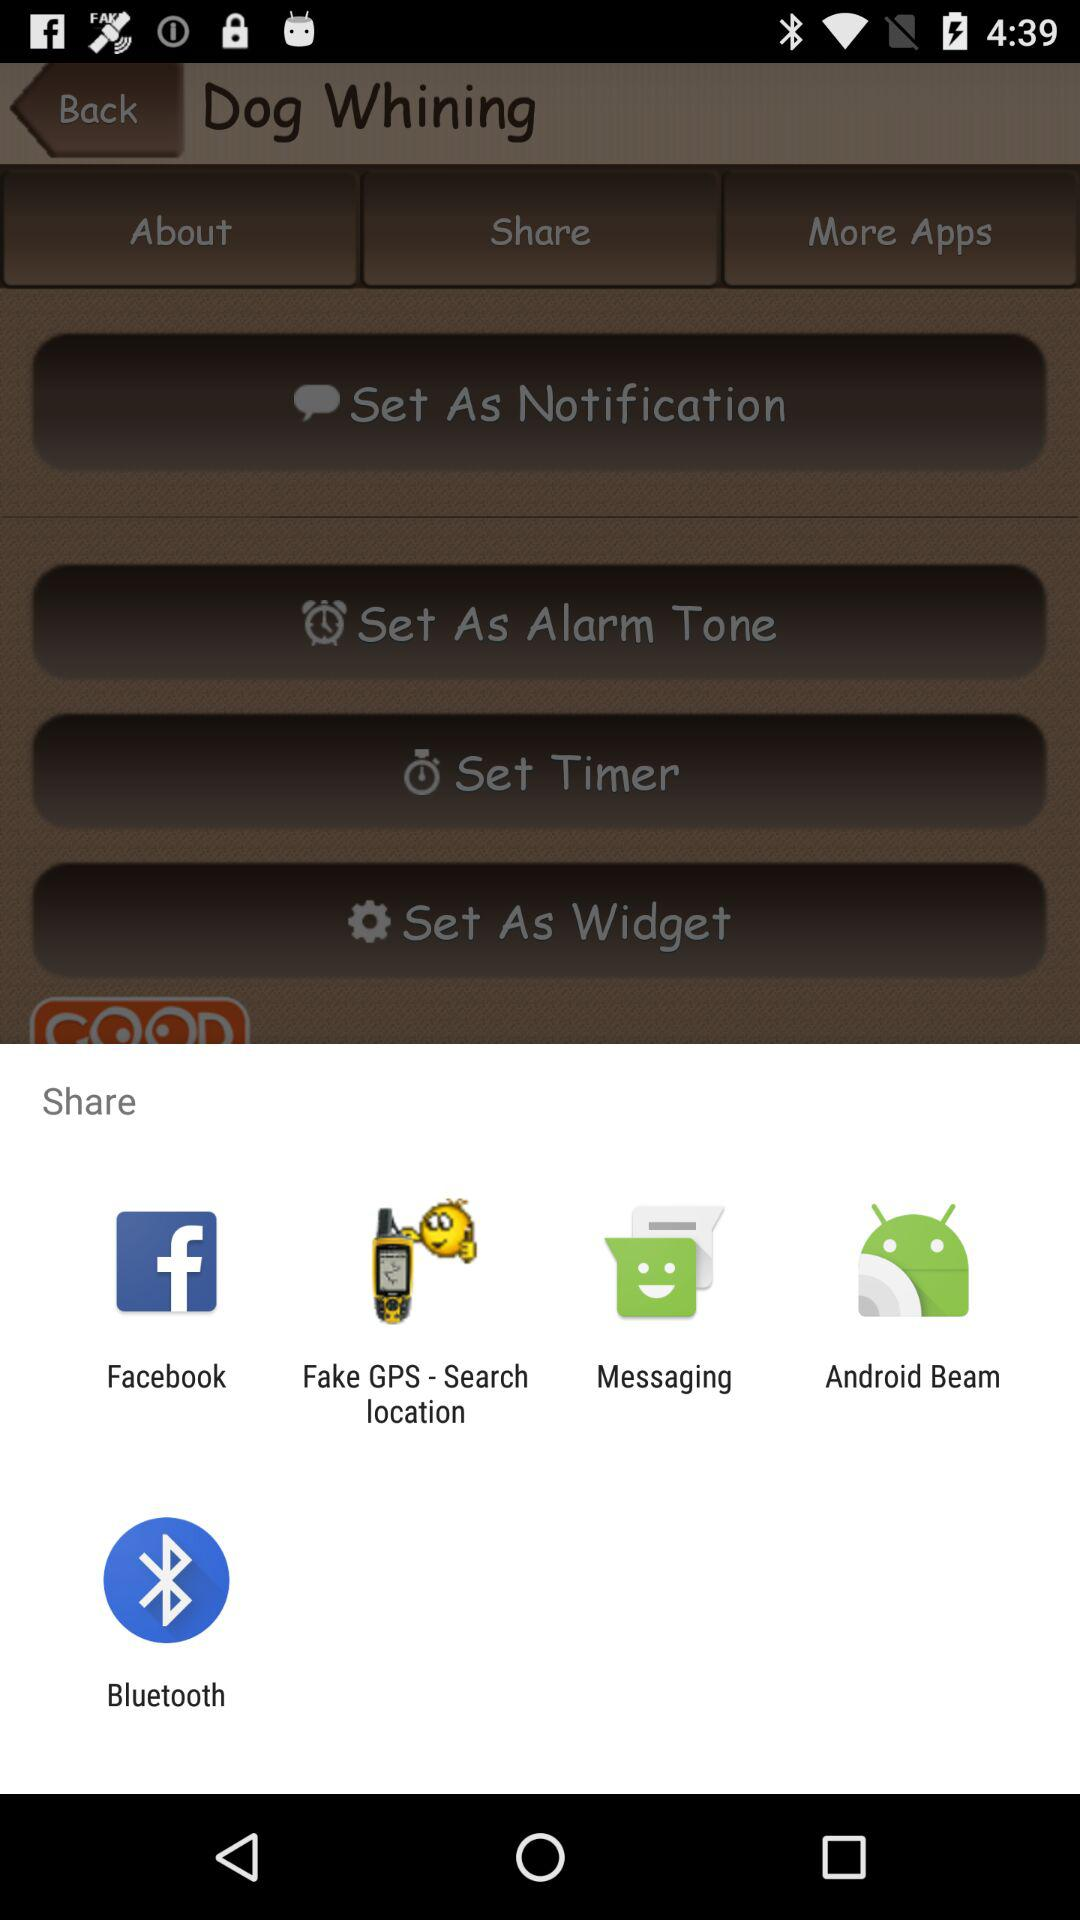What application can I use to share the content? You can use "Facebook", "Fake GPS - Search location", "Messaging", "Android Beam" and "Bluetooth" to share the content. 